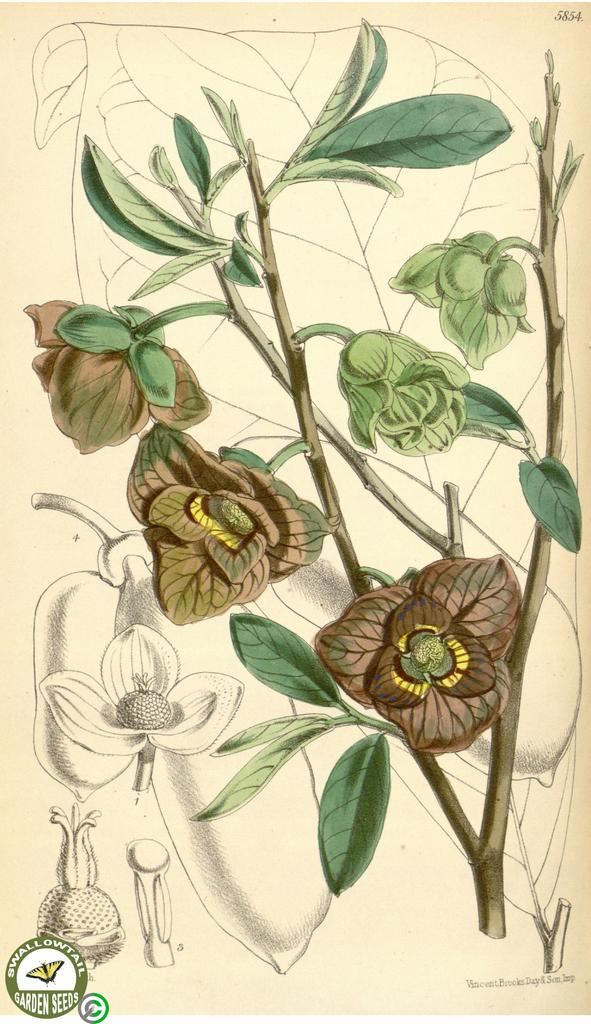What type of artwork is depicted in the image? The image is a painting. What natural elements are present in the painting? There are flowers, leaves, and stems in the painting. Is there any text included in the painting? Yes, there is text at the bottom of the painting. Where is the logo located in the painting? The logo is in the left side bottom corner of the painting. What type of alarm can be heard going off in the painting? There is no alarm present in the painting; it is a still image of flowers, leaves, and stems. Can you describe the bun that the giant is holding in the painting? There are no giants or buns present in the painting; it features flowers, leaves, and stems. 